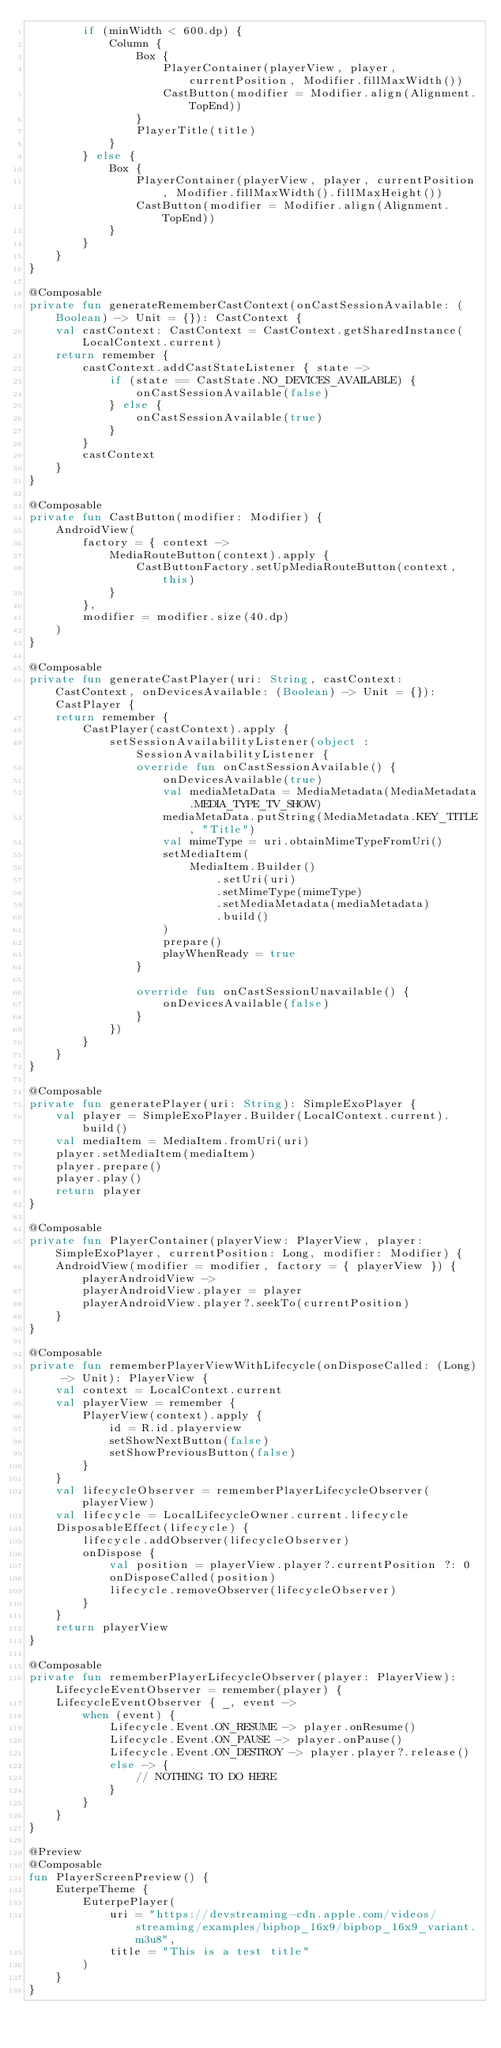Convert code to text. <code><loc_0><loc_0><loc_500><loc_500><_Kotlin_>        if (minWidth < 600.dp) {
            Column {
                Box {
                    PlayerContainer(playerView, player, currentPosition, Modifier.fillMaxWidth())
                    CastButton(modifier = Modifier.align(Alignment.TopEnd))
                }
                PlayerTitle(title)
            }
        } else {
            Box {
                PlayerContainer(playerView, player, currentPosition, Modifier.fillMaxWidth().fillMaxHeight())
                CastButton(modifier = Modifier.align(Alignment.TopEnd))
            }
        }
    }
}

@Composable
private fun generateRememberCastContext(onCastSessionAvailable: (Boolean) -> Unit = {}): CastContext {
    val castContext: CastContext = CastContext.getSharedInstance(LocalContext.current)
    return remember {
        castContext.addCastStateListener { state ->
            if (state == CastState.NO_DEVICES_AVAILABLE) {
                onCastSessionAvailable(false)
            } else {
                onCastSessionAvailable(true)
            }
        }
        castContext
    }
}

@Composable
private fun CastButton(modifier: Modifier) {
    AndroidView(
        factory = { context ->
            MediaRouteButton(context).apply {
                CastButtonFactory.setUpMediaRouteButton(context, this)
            }
        },
        modifier = modifier.size(40.dp)
    )
}

@Composable
private fun generateCastPlayer(uri: String, castContext: CastContext, onDevicesAvailable: (Boolean) -> Unit = {}): CastPlayer {
    return remember {
        CastPlayer(castContext).apply {
            setSessionAvailabilityListener(object : SessionAvailabilityListener {
                override fun onCastSessionAvailable() {
                    onDevicesAvailable(true)
                    val mediaMetaData = MediaMetadata(MediaMetadata.MEDIA_TYPE_TV_SHOW)
                    mediaMetaData.putString(MediaMetadata.KEY_TITLE, "Title")
                    val mimeType = uri.obtainMimeTypeFromUri()
                    setMediaItem(
                        MediaItem.Builder()
                            .setUri(uri)
                            .setMimeType(mimeType)
                            .setMediaMetadata(mediaMetadata)
                            .build()
                    )
                    prepare()
                    playWhenReady = true
                }

                override fun onCastSessionUnavailable() {
                    onDevicesAvailable(false)
                }
            })
        }
    }
}

@Composable
private fun generatePlayer(uri: String): SimpleExoPlayer {
    val player = SimpleExoPlayer.Builder(LocalContext.current).build()
    val mediaItem = MediaItem.fromUri(uri)
    player.setMediaItem(mediaItem)
    player.prepare()
    player.play()
    return player
}

@Composable
private fun PlayerContainer(playerView: PlayerView, player: SimpleExoPlayer, currentPosition: Long, modifier: Modifier) {
    AndroidView(modifier = modifier, factory = { playerView }) { playerAndroidView ->
        playerAndroidView.player = player
        playerAndroidView.player?.seekTo(currentPosition)
    }
}

@Composable
private fun rememberPlayerViewWithLifecycle(onDisposeCalled: (Long) -> Unit): PlayerView {
    val context = LocalContext.current
    val playerView = remember {
        PlayerView(context).apply {
            id = R.id.playerview
            setShowNextButton(false)
            setShowPreviousButton(false)
        }
    }
    val lifecycleObserver = rememberPlayerLifecycleObserver(playerView)
    val lifecycle = LocalLifecycleOwner.current.lifecycle
    DisposableEffect(lifecycle) {
        lifecycle.addObserver(lifecycleObserver)
        onDispose {
            val position = playerView.player?.currentPosition ?: 0
            onDisposeCalled(position)
            lifecycle.removeObserver(lifecycleObserver)
        }
    }
    return playerView
}

@Composable
private fun rememberPlayerLifecycleObserver(player: PlayerView): LifecycleEventObserver = remember(player) {
    LifecycleEventObserver { _, event ->
        when (event) {
            Lifecycle.Event.ON_RESUME -> player.onResume()
            Lifecycle.Event.ON_PAUSE -> player.onPause()
            Lifecycle.Event.ON_DESTROY -> player.player?.release()
            else -> {
                // NOTHING TO DO HERE
            }
        }
    }
}

@Preview
@Composable
fun PlayerScreenPreview() {
    EuterpeTheme {
        EuterpePlayer(
            uri = "https://devstreaming-cdn.apple.com/videos/streaming/examples/bipbop_16x9/bipbop_16x9_variant.m3u8",
            title = "This is a test title"
        )
    }
}
</code> 